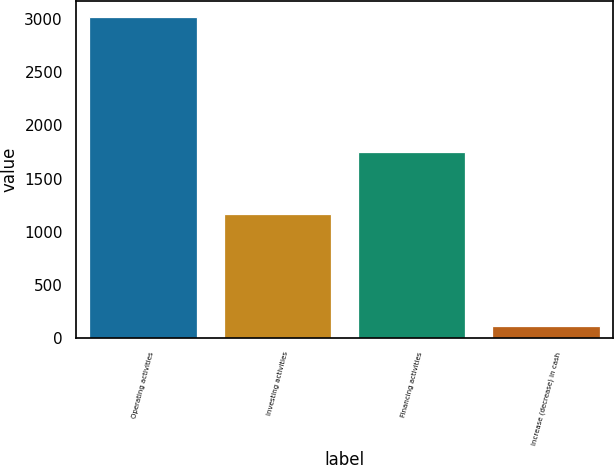Convert chart to OTSL. <chart><loc_0><loc_0><loc_500><loc_500><bar_chart><fcel>Operating activities<fcel>Investing activities<fcel>Financing activities<fcel>Increase (decrease) in cash<nl><fcel>3022<fcel>1164<fcel>1746<fcel>112<nl></chart> 